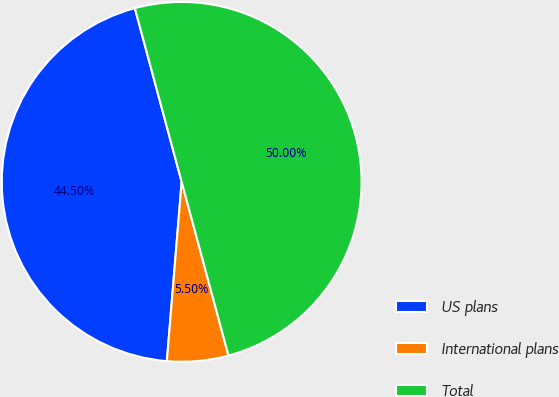Convert chart to OTSL. <chart><loc_0><loc_0><loc_500><loc_500><pie_chart><fcel>US plans<fcel>International plans<fcel>Total<nl><fcel>44.5%<fcel>5.5%<fcel>50.0%<nl></chart> 